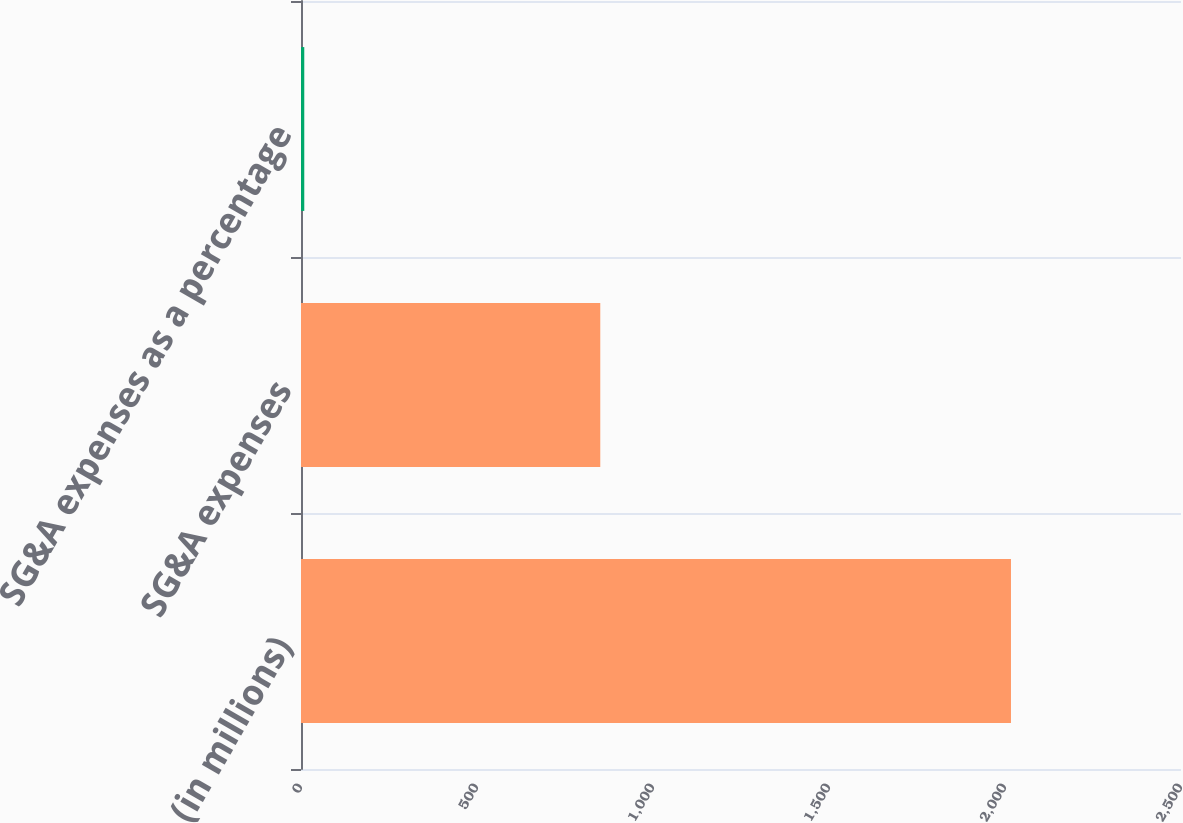<chart> <loc_0><loc_0><loc_500><loc_500><bar_chart><fcel>(in millions)<fcel>SG&A expenses<fcel>SG&A expenses as a percentage<nl><fcel>2017<fcel>850.2<fcel>9.3<nl></chart> 